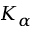Convert formula to latex. <formula><loc_0><loc_0><loc_500><loc_500>K _ { \alpha }</formula> 